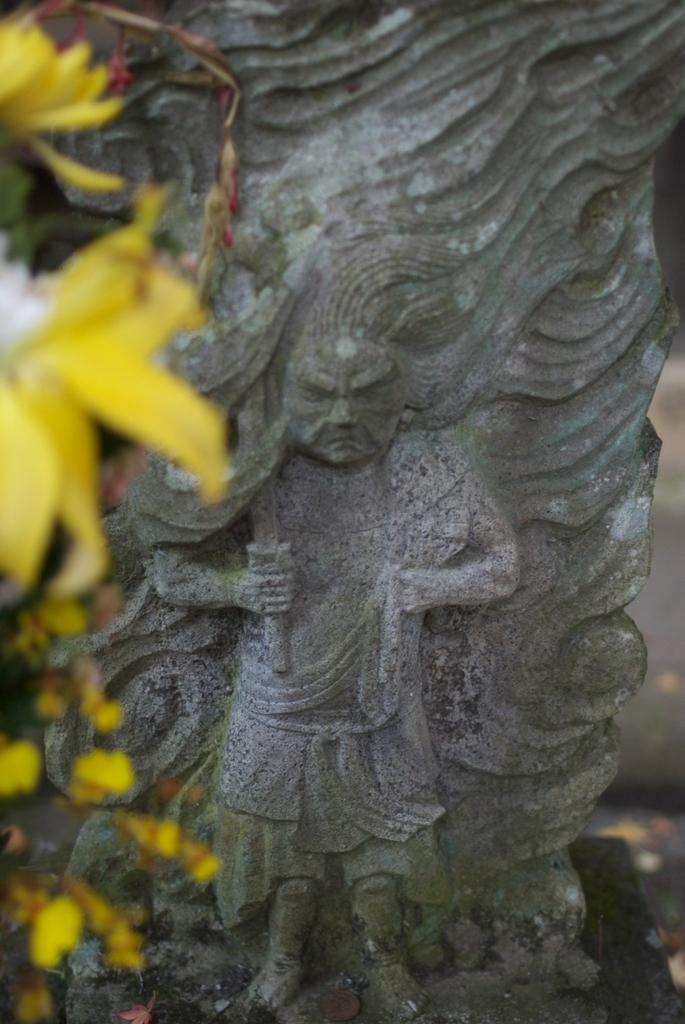What is the main subject in the image? There is a sculpture in the image. What type of flowers can be seen on the left side of the image? There are yellow color flowers on the left side of the image. What type of bomb can be seen in the image? There is no bomb present in the image. What type of teeth can be seen in the image? There are no teeth visible in the image. 